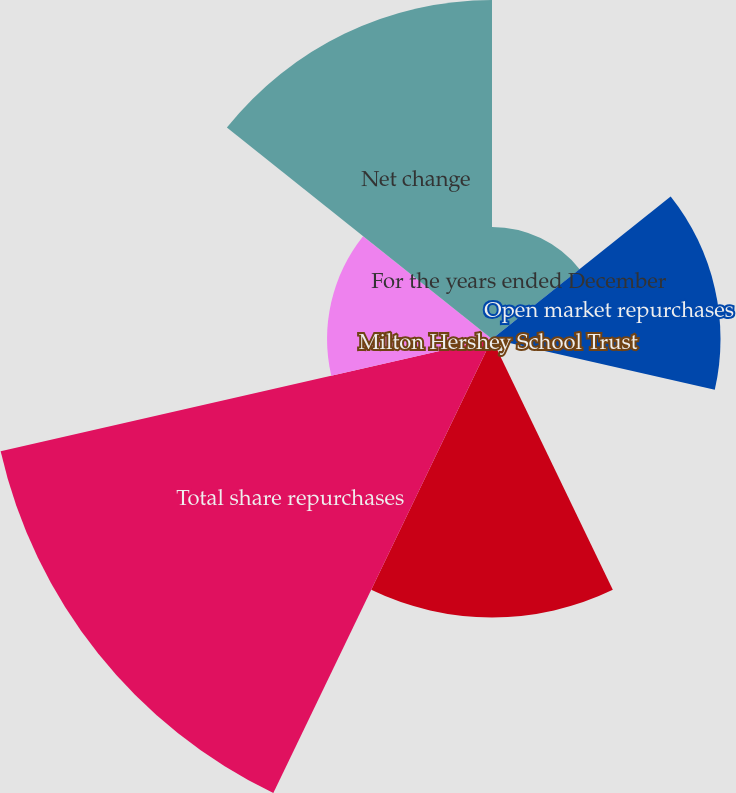Convert chart to OTSL. <chart><loc_0><loc_0><loc_500><loc_500><pie_chart><fcel>For the years ended December<fcel>Open market repurchases<fcel>Milton Hershey School Trust<fcel>Shares repurchased to replace<fcel>Total share repurchases<fcel>Shares issued for stock<fcel>Net change<nl><fcel>6.87%<fcel>14.01%<fcel>0.24%<fcel>17.07%<fcel>30.9%<fcel>10.11%<fcel>20.79%<nl></chart> 